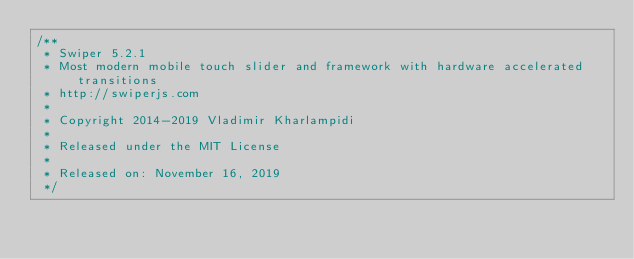<code> <loc_0><loc_0><loc_500><loc_500><_CSS_>/**
 * Swiper 5.2.1
 * Most modern mobile touch slider and framework with hardware accelerated transitions
 * http://swiperjs.com
 *
 * Copyright 2014-2019 Vladimir Kharlampidi
 *
 * Released under the MIT License
 *
 * Released on: November 16, 2019
 */
</code> 